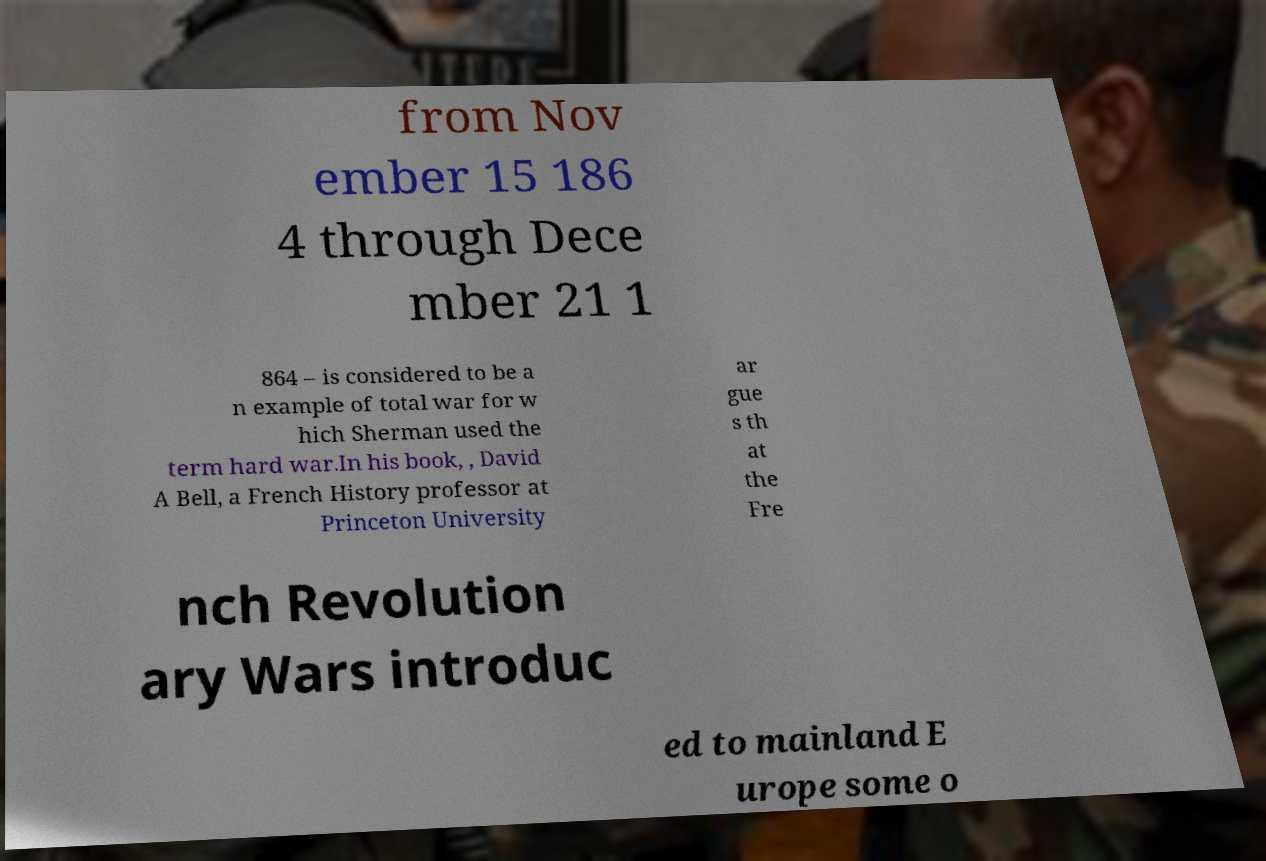Please identify and transcribe the text found in this image. from Nov ember 15 186 4 through Dece mber 21 1 864 – is considered to be a n example of total war for w hich Sherman used the term hard war.In his book, , David A Bell, a French History professor at Princeton University ar gue s th at the Fre nch Revolution ary Wars introduc ed to mainland E urope some o 